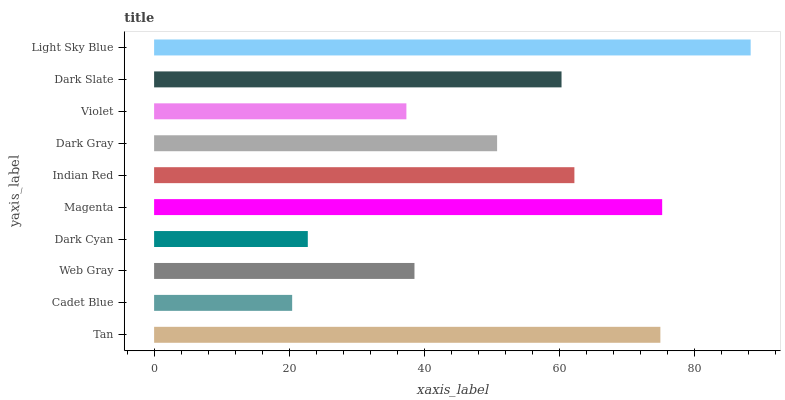Is Cadet Blue the minimum?
Answer yes or no. Yes. Is Light Sky Blue the maximum?
Answer yes or no. Yes. Is Web Gray the minimum?
Answer yes or no. No. Is Web Gray the maximum?
Answer yes or no. No. Is Web Gray greater than Cadet Blue?
Answer yes or no. Yes. Is Cadet Blue less than Web Gray?
Answer yes or no. Yes. Is Cadet Blue greater than Web Gray?
Answer yes or no. No. Is Web Gray less than Cadet Blue?
Answer yes or no. No. Is Dark Slate the high median?
Answer yes or no. Yes. Is Dark Gray the low median?
Answer yes or no. Yes. Is Indian Red the high median?
Answer yes or no. No. Is Light Sky Blue the low median?
Answer yes or no. No. 